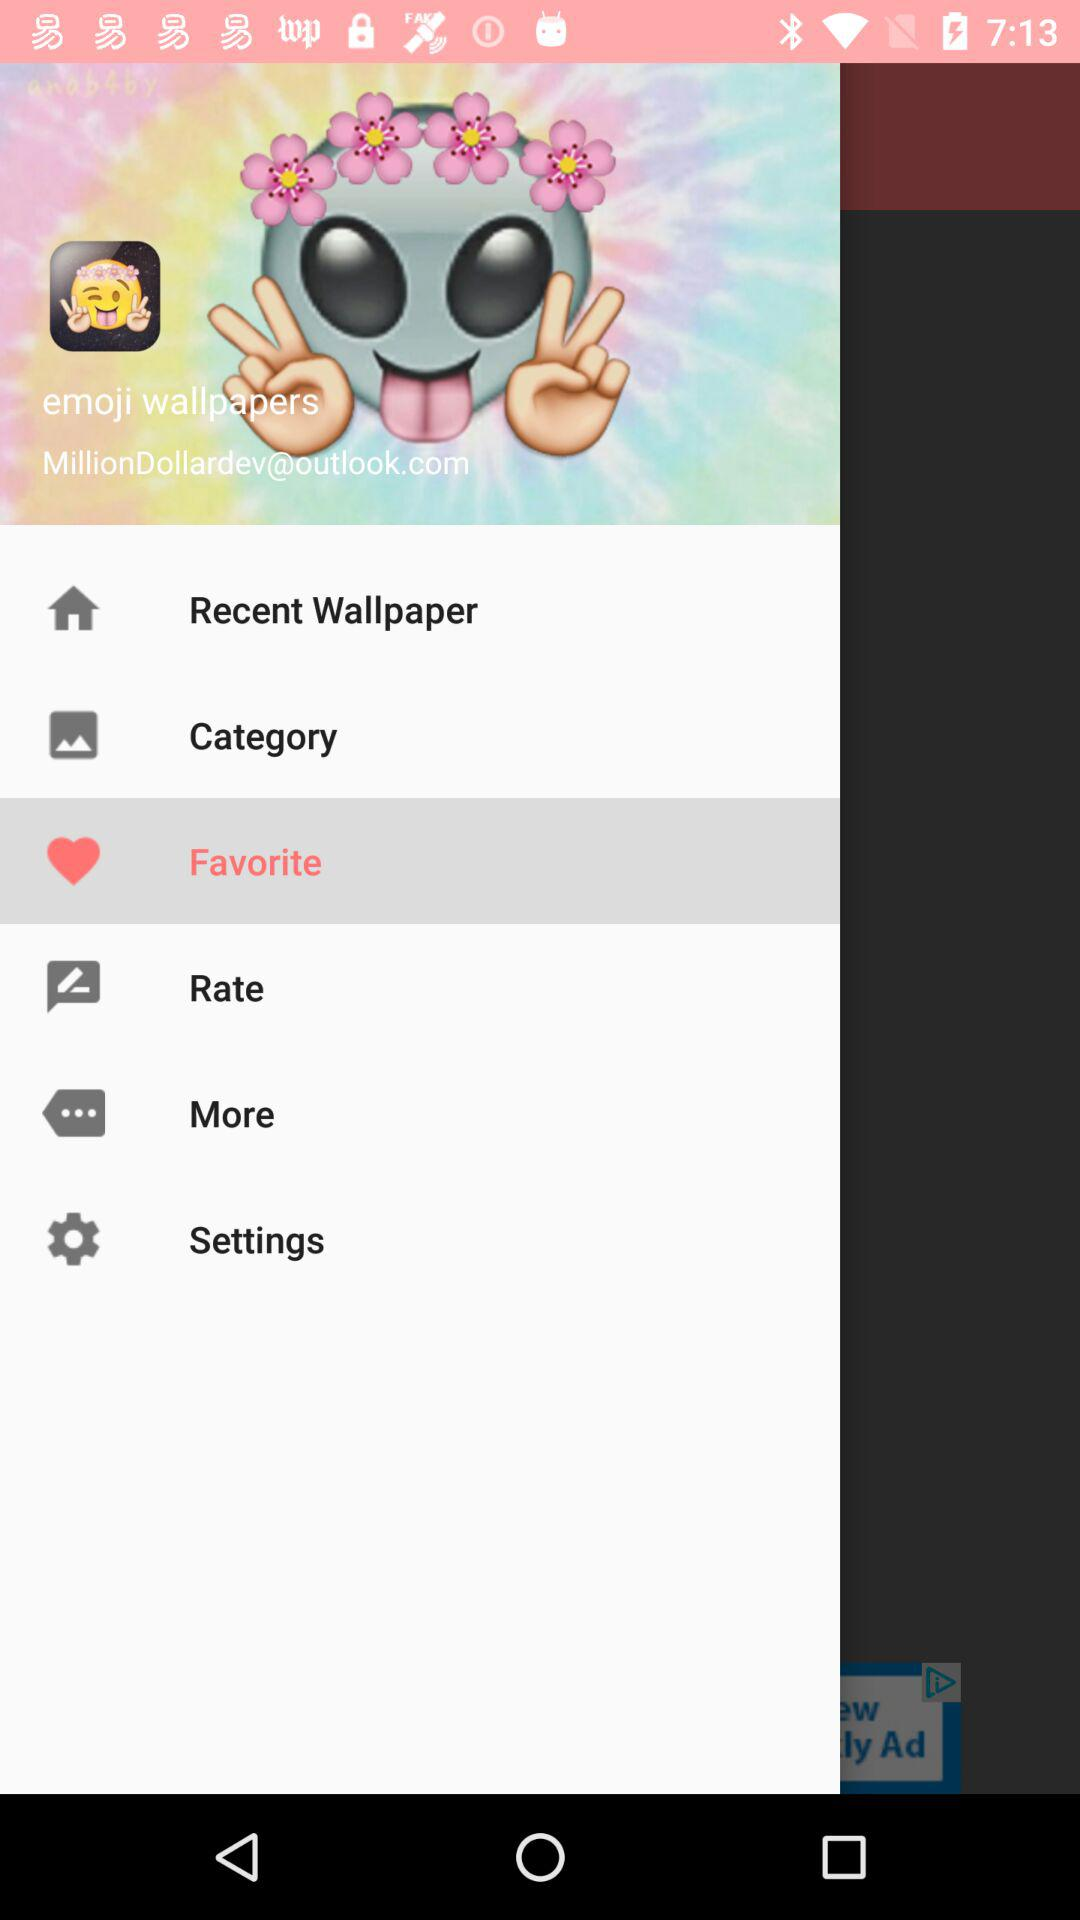What is the email address? The email address is MillionDollardev@outlook.com. 